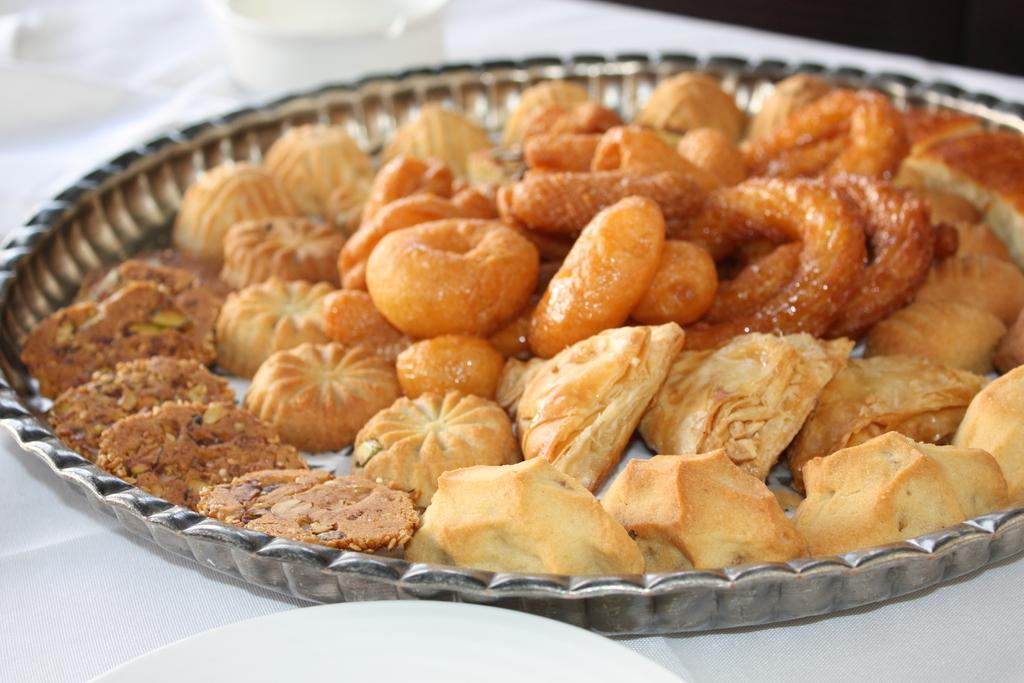What is on the plate in the foreground of the image? There is food on the plate in the foreground of the image. What can be seen in the background of the image? There is an object in the background of the image. What color is the surface at the bottom of the image? The surface at the bottom of the image is white-colored. What type of hair can be seen on the plate in the image? There is no hair present on the plate in the image; it contains food. 